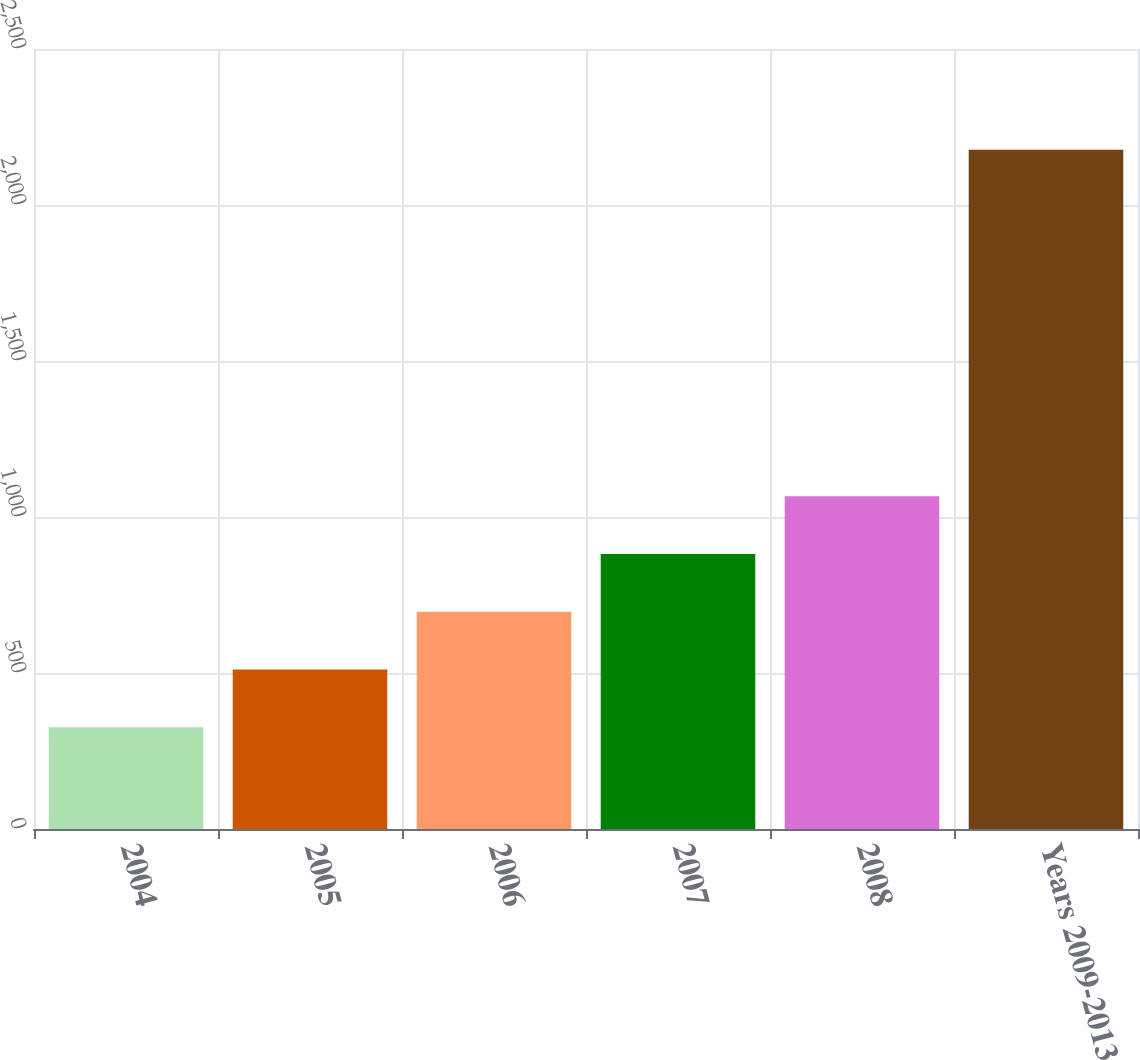<chart> <loc_0><loc_0><loc_500><loc_500><bar_chart><fcel>2004<fcel>2005<fcel>2006<fcel>2007<fcel>2008<fcel>Years 2009-2013<nl><fcel>326<fcel>511.1<fcel>696.2<fcel>881.3<fcel>1066.4<fcel>2177<nl></chart> 